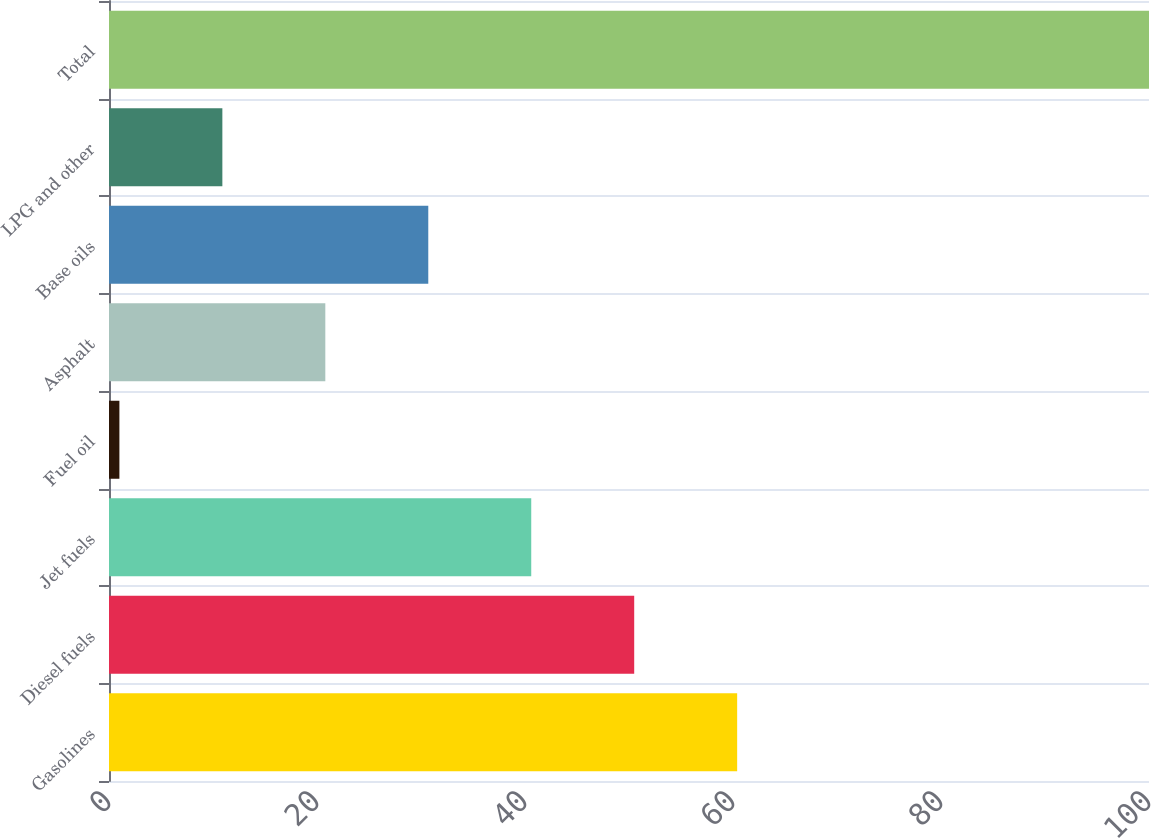<chart> <loc_0><loc_0><loc_500><loc_500><bar_chart><fcel>Gasolines<fcel>Diesel fuels<fcel>Jet fuels<fcel>Fuel oil<fcel>Asphalt<fcel>Base oils<fcel>LPG and other<fcel>Total<nl><fcel>60.4<fcel>50.5<fcel>40.6<fcel>1<fcel>20.8<fcel>30.7<fcel>10.9<fcel>100<nl></chart> 